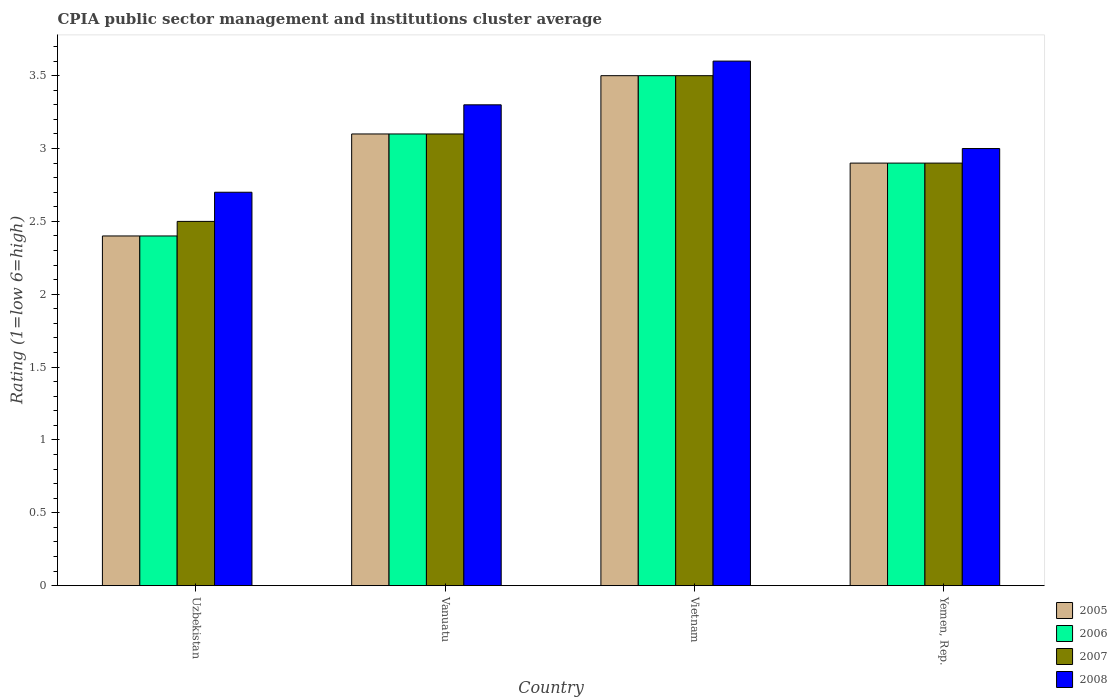How many different coloured bars are there?
Give a very brief answer. 4. Are the number of bars per tick equal to the number of legend labels?
Your answer should be compact. Yes. What is the label of the 1st group of bars from the left?
Provide a short and direct response. Uzbekistan. Across all countries, what is the maximum CPIA rating in 2006?
Provide a succinct answer. 3.5. Across all countries, what is the minimum CPIA rating in 2005?
Provide a short and direct response. 2.4. In which country was the CPIA rating in 2008 maximum?
Your response must be concise. Vietnam. In which country was the CPIA rating in 2008 minimum?
Ensure brevity in your answer.  Uzbekistan. What is the difference between the CPIA rating in 2008 in Vanuatu and that in Yemen, Rep.?
Keep it short and to the point. 0.3. What is the difference between the CPIA rating in 2008 in Vanuatu and the CPIA rating in 2006 in Uzbekistan?
Your answer should be compact. 0.9. What is the average CPIA rating in 2005 per country?
Provide a short and direct response. 2.98. What is the ratio of the CPIA rating in 2006 in Uzbekistan to that in Vanuatu?
Provide a short and direct response. 0.77. Is the CPIA rating in 2008 in Uzbekistan less than that in Vanuatu?
Your answer should be very brief. Yes. What is the difference between the highest and the second highest CPIA rating in 2006?
Keep it short and to the point. 0.2. What is the difference between the highest and the lowest CPIA rating in 2008?
Give a very brief answer. 0.9. What does the 3rd bar from the right in Vietnam represents?
Give a very brief answer. 2006. Is it the case that in every country, the sum of the CPIA rating in 2005 and CPIA rating in 2008 is greater than the CPIA rating in 2007?
Your response must be concise. Yes. Are all the bars in the graph horizontal?
Keep it short and to the point. No. How many countries are there in the graph?
Provide a short and direct response. 4. What is the difference between two consecutive major ticks on the Y-axis?
Make the answer very short. 0.5. Are the values on the major ticks of Y-axis written in scientific E-notation?
Provide a short and direct response. No. How many legend labels are there?
Give a very brief answer. 4. What is the title of the graph?
Keep it short and to the point. CPIA public sector management and institutions cluster average. Does "1970" appear as one of the legend labels in the graph?
Provide a short and direct response. No. What is the label or title of the X-axis?
Your answer should be compact. Country. What is the Rating (1=low 6=high) in 2006 in Uzbekistan?
Make the answer very short. 2.4. What is the Rating (1=low 6=high) in 2007 in Uzbekistan?
Offer a terse response. 2.5. What is the Rating (1=low 6=high) in 2007 in Vanuatu?
Keep it short and to the point. 3.1. What is the Rating (1=low 6=high) in 2006 in Vietnam?
Ensure brevity in your answer.  3.5. What is the Rating (1=low 6=high) of 2008 in Vietnam?
Keep it short and to the point. 3.6. What is the Rating (1=low 6=high) in 2005 in Yemen, Rep.?
Your answer should be very brief. 2.9. What is the Rating (1=low 6=high) of 2008 in Yemen, Rep.?
Your answer should be compact. 3. Across all countries, what is the maximum Rating (1=low 6=high) in 2006?
Your answer should be very brief. 3.5. Across all countries, what is the maximum Rating (1=low 6=high) in 2008?
Give a very brief answer. 3.6. Across all countries, what is the minimum Rating (1=low 6=high) of 2005?
Provide a short and direct response. 2.4. What is the total Rating (1=low 6=high) of 2006 in the graph?
Ensure brevity in your answer.  11.9. What is the total Rating (1=low 6=high) in 2007 in the graph?
Offer a very short reply. 12. What is the total Rating (1=low 6=high) of 2008 in the graph?
Give a very brief answer. 12.6. What is the difference between the Rating (1=low 6=high) of 2007 in Uzbekistan and that in Vanuatu?
Give a very brief answer. -0.6. What is the difference between the Rating (1=low 6=high) of 2008 in Uzbekistan and that in Vanuatu?
Your answer should be very brief. -0.6. What is the difference between the Rating (1=low 6=high) in 2005 in Uzbekistan and that in Vietnam?
Ensure brevity in your answer.  -1.1. What is the difference between the Rating (1=low 6=high) in 2008 in Uzbekistan and that in Vietnam?
Your response must be concise. -0.9. What is the difference between the Rating (1=low 6=high) of 2005 in Uzbekistan and that in Yemen, Rep.?
Keep it short and to the point. -0.5. What is the difference between the Rating (1=low 6=high) in 2008 in Uzbekistan and that in Yemen, Rep.?
Provide a succinct answer. -0.3. What is the difference between the Rating (1=low 6=high) in 2005 in Vanuatu and that in Vietnam?
Offer a terse response. -0.4. What is the difference between the Rating (1=low 6=high) of 2008 in Vanuatu and that in Vietnam?
Provide a short and direct response. -0.3. What is the difference between the Rating (1=low 6=high) of 2005 in Vanuatu and that in Yemen, Rep.?
Offer a terse response. 0.2. What is the difference between the Rating (1=low 6=high) in 2008 in Vanuatu and that in Yemen, Rep.?
Your answer should be very brief. 0.3. What is the difference between the Rating (1=low 6=high) of 2006 in Vietnam and that in Yemen, Rep.?
Keep it short and to the point. 0.6. What is the difference between the Rating (1=low 6=high) of 2005 in Uzbekistan and the Rating (1=low 6=high) of 2006 in Vanuatu?
Provide a short and direct response. -0.7. What is the difference between the Rating (1=low 6=high) in 2006 in Uzbekistan and the Rating (1=low 6=high) in 2007 in Vanuatu?
Your response must be concise. -0.7. What is the difference between the Rating (1=low 6=high) of 2007 in Uzbekistan and the Rating (1=low 6=high) of 2008 in Vanuatu?
Give a very brief answer. -0.8. What is the difference between the Rating (1=low 6=high) of 2005 in Uzbekistan and the Rating (1=low 6=high) of 2007 in Vietnam?
Your answer should be very brief. -1.1. What is the difference between the Rating (1=low 6=high) of 2005 in Uzbekistan and the Rating (1=low 6=high) of 2008 in Vietnam?
Offer a terse response. -1.2. What is the difference between the Rating (1=low 6=high) in 2007 in Uzbekistan and the Rating (1=low 6=high) in 2008 in Vietnam?
Make the answer very short. -1.1. What is the difference between the Rating (1=low 6=high) in 2005 in Uzbekistan and the Rating (1=low 6=high) in 2006 in Yemen, Rep.?
Make the answer very short. -0.5. What is the difference between the Rating (1=low 6=high) of 2005 in Uzbekistan and the Rating (1=low 6=high) of 2007 in Yemen, Rep.?
Provide a succinct answer. -0.5. What is the difference between the Rating (1=low 6=high) of 2005 in Uzbekistan and the Rating (1=low 6=high) of 2008 in Yemen, Rep.?
Keep it short and to the point. -0.6. What is the difference between the Rating (1=low 6=high) of 2005 in Vanuatu and the Rating (1=low 6=high) of 2008 in Vietnam?
Make the answer very short. -0.5. What is the difference between the Rating (1=low 6=high) of 2006 in Vanuatu and the Rating (1=low 6=high) of 2007 in Vietnam?
Your answer should be very brief. -0.4. What is the difference between the Rating (1=low 6=high) of 2007 in Vanuatu and the Rating (1=low 6=high) of 2008 in Vietnam?
Offer a terse response. -0.5. What is the difference between the Rating (1=low 6=high) of 2005 in Vanuatu and the Rating (1=low 6=high) of 2006 in Yemen, Rep.?
Provide a short and direct response. 0.2. What is the difference between the Rating (1=low 6=high) of 2005 in Vanuatu and the Rating (1=low 6=high) of 2007 in Yemen, Rep.?
Make the answer very short. 0.2. What is the difference between the Rating (1=low 6=high) of 2005 in Vanuatu and the Rating (1=low 6=high) of 2008 in Yemen, Rep.?
Make the answer very short. 0.1. What is the difference between the Rating (1=low 6=high) in 2007 in Vanuatu and the Rating (1=low 6=high) in 2008 in Yemen, Rep.?
Ensure brevity in your answer.  0.1. What is the difference between the Rating (1=low 6=high) in 2005 in Vietnam and the Rating (1=low 6=high) in 2006 in Yemen, Rep.?
Make the answer very short. 0.6. What is the difference between the Rating (1=low 6=high) in 2005 in Vietnam and the Rating (1=low 6=high) in 2008 in Yemen, Rep.?
Give a very brief answer. 0.5. What is the difference between the Rating (1=low 6=high) of 2007 in Vietnam and the Rating (1=low 6=high) of 2008 in Yemen, Rep.?
Ensure brevity in your answer.  0.5. What is the average Rating (1=low 6=high) in 2005 per country?
Keep it short and to the point. 2.98. What is the average Rating (1=low 6=high) of 2006 per country?
Your answer should be compact. 2.98. What is the average Rating (1=low 6=high) in 2008 per country?
Your response must be concise. 3.15. What is the difference between the Rating (1=low 6=high) of 2005 and Rating (1=low 6=high) of 2006 in Uzbekistan?
Provide a succinct answer. 0. What is the difference between the Rating (1=low 6=high) in 2005 and Rating (1=low 6=high) in 2007 in Uzbekistan?
Your response must be concise. -0.1. What is the difference between the Rating (1=low 6=high) in 2007 and Rating (1=low 6=high) in 2008 in Uzbekistan?
Your answer should be compact. -0.2. What is the difference between the Rating (1=low 6=high) of 2005 and Rating (1=low 6=high) of 2008 in Vanuatu?
Your answer should be very brief. -0.2. What is the difference between the Rating (1=low 6=high) of 2007 and Rating (1=low 6=high) of 2008 in Vanuatu?
Keep it short and to the point. -0.2. What is the difference between the Rating (1=low 6=high) of 2005 and Rating (1=low 6=high) of 2007 in Vietnam?
Provide a succinct answer. 0. What is the difference between the Rating (1=low 6=high) of 2006 and Rating (1=low 6=high) of 2007 in Vietnam?
Your answer should be compact. 0. What is the difference between the Rating (1=low 6=high) in 2007 and Rating (1=low 6=high) in 2008 in Vietnam?
Ensure brevity in your answer.  -0.1. What is the difference between the Rating (1=low 6=high) of 2005 and Rating (1=low 6=high) of 2006 in Yemen, Rep.?
Provide a succinct answer. 0. What is the difference between the Rating (1=low 6=high) of 2005 and Rating (1=low 6=high) of 2008 in Yemen, Rep.?
Give a very brief answer. -0.1. What is the difference between the Rating (1=low 6=high) in 2006 and Rating (1=low 6=high) in 2008 in Yemen, Rep.?
Ensure brevity in your answer.  -0.1. What is the ratio of the Rating (1=low 6=high) in 2005 in Uzbekistan to that in Vanuatu?
Give a very brief answer. 0.77. What is the ratio of the Rating (1=low 6=high) of 2006 in Uzbekistan to that in Vanuatu?
Ensure brevity in your answer.  0.77. What is the ratio of the Rating (1=low 6=high) of 2007 in Uzbekistan to that in Vanuatu?
Offer a very short reply. 0.81. What is the ratio of the Rating (1=low 6=high) of 2008 in Uzbekistan to that in Vanuatu?
Keep it short and to the point. 0.82. What is the ratio of the Rating (1=low 6=high) of 2005 in Uzbekistan to that in Vietnam?
Make the answer very short. 0.69. What is the ratio of the Rating (1=low 6=high) in 2006 in Uzbekistan to that in Vietnam?
Keep it short and to the point. 0.69. What is the ratio of the Rating (1=low 6=high) of 2007 in Uzbekistan to that in Vietnam?
Offer a terse response. 0.71. What is the ratio of the Rating (1=low 6=high) in 2008 in Uzbekistan to that in Vietnam?
Your answer should be very brief. 0.75. What is the ratio of the Rating (1=low 6=high) in 2005 in Uzbekistan to that in Yemen, Rep.?
Offer a very short reply. 0.83. What is the ratio of the Rating (1=low 6=high) in 2006 in Uzbekistan to that in Yemen, Rep.?
Offer a very short reply. 0.83. What is the ratio of the Rating (1=low 6=high) in 2007 in Uzbekistan to that in Yemen, Rep.?
Keep it short and to the point. 0.86. What is the ratio of the Rating (1=low 6=high) in 2008 in Uzbekistan to that in Yemen, Rep.?
Your response must be concise. 0.9. What is the ratio of the Rating (1=low 6=high) of 2005 in Vanuatu to that in Vietnam?
Give a very brief answer. 0.89. What is the ratio of the Rating (1=low 6=high) of 2006 in Vanuatu to that in Vietnam?
Your answer should be compact. 0.89. What is the ratio of the Rating (1=low 6=high) of 2007 in Vanuatu to that in Vietnam?
Ensure brevity in your answer.  0.89. What is the ratio of the Rating (1=low 6=high) of 2008 in Vanuatu to that in Vietnam?
Your answer should be very brief. 0.92. What is the ratio of the Rating (1=low 6=high) in 2005 in Vanuatu to that in Yemen, Rep.?
Your response must be concise. 1.07. What is the ratio of the Rating (1=low 6=high) of 2006 in Vanuatu to that in Yemen, Rep.?
Make the answer very short. 1.07. What is the ratio of the Rating (1=low 6=high) of 2007 in Vanuatu to that in Yemen, Rep.?
Give a very brief answer. 1.07. What is the ratio of the Rating (1=low 6=high) of 2005 in Vietnam to that in Yemen, Rep.?
Offer a very short reply. 1.21. What is the ratio of the Rating (1=low 6=high) of 2006 in Vietnam to that in Yemen, Rep.?
Provide a short and direct response. 1.21. What is the ratio of the Rating (1=low 6=high) of 2007 in Vietnam to that in Yemen, Rep.?
Make the answer very short. 1.21. What is the difference between the highest and the lowest Rating (1=low 6=high) of 2006?
Provide a succinct answer. 1.1. What is the difference between the highest and the lowest Rating (1=low 6=high) of 2008?
Ensure brevity in your answer.  0.9. 